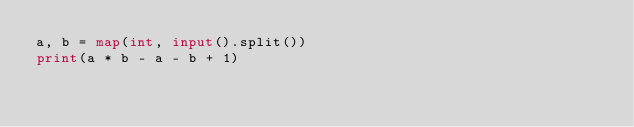<code> <loc_0><loc_0><loc_500><loc_500><_Python_>a, b = map(int, input().split())
print(a * b - a - b + 1)</code> 